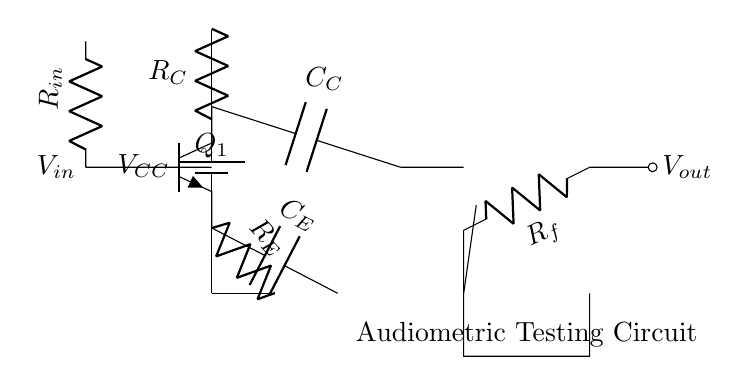What is the input resistor value? The input resistor is labeled as R_in in the diagram, but the value is not specified in the provided code or visually, so we cannot determine its numerical value.
Answer: R_in What type of transistor is used in the circuit? The transistor in the circuit is marked as Q_1 and is represented as an npn transistor in the diagram, indicating its type.
Answer: npn What is the configuration of the operational amplifier? The diagram shows a feedback resistor connected to the output of the op-amp, indicating it is configured as a negative feedback amplifier, which is common for signal amplification.
Answer: Negative feedback How many capacitors are in the circuit? Observing the diagram reveals three capacitors: C_E (emitter capacitor), C_C (coupling capacitor), and one associated with the feedback network, giving a total of two distinct capacitors.
Answer: 3 What is the output node labeled as? In the circuit, the output node is marked clearly as V_out, indicating where the amplified signal is available for use.
Answer: V_out What is the role of the emitter resistor? The emitter resistor, labeled R_E, is connected to the emitter of the transistor and is used for biasing the transistor and ensuring stability in the circuit.
Answer: Biasing and stability 